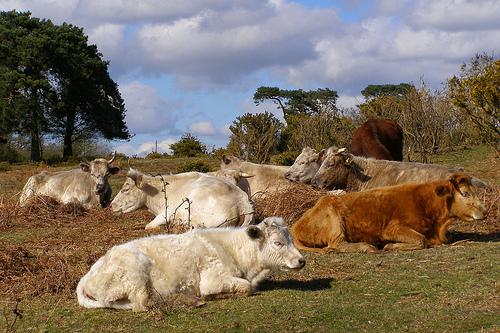Question: what animals are these?
Choices:
A. Cows.
B. Dogs.
C. Elephants.
D. Zebras.
Answer with the letter. Answer: A Question: when was the photo taken?
Choices:
A. Daytime.
B. Nighttime.
C. On his birthday.
D. Yesterday.
Answer with the letter. Answer: A Question: what is in the sky?
Choices:
A. Stars.
B. The sun.
C. The moon.
D. Clouds.
Answer with the letter. Answer: D Question: who else is pictured?
Choices:
A. Parents.
B. Daughter.
C. Nobody.
D. Friends.
Answer with the letter. Answer: C Question: where are the cows?
Choices:
A. In the pasture.
B. Barn.
C. Farm.
D. The pen.
Answer with the letter. Answer: A Question: why are the cows lying down?
Choices:
A. It's hot.
B. Sleeping.
C. They are tired.
D. They are resting.
Answer with the letter. Answer: D 